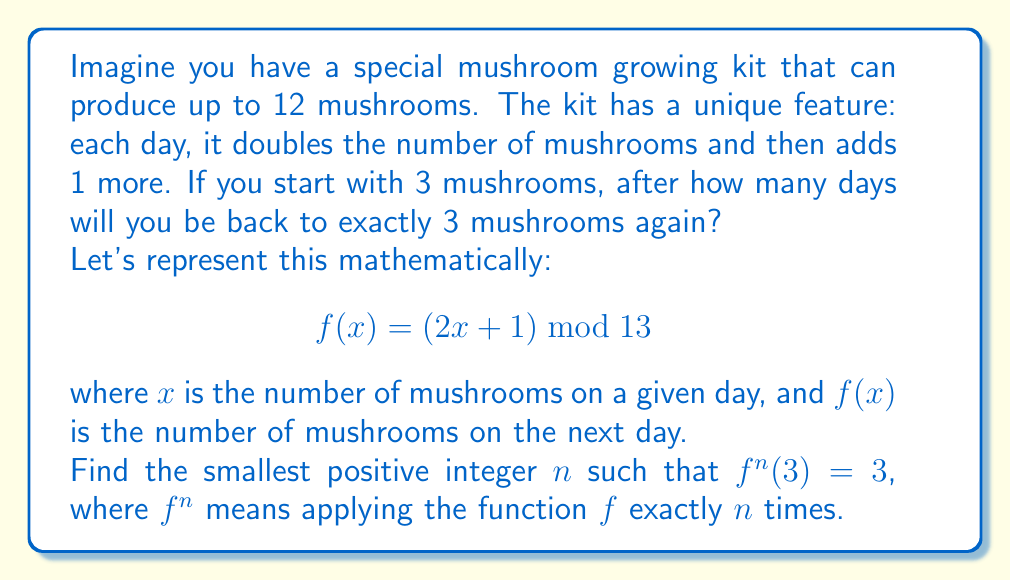Can you solve this math problem? To solve this problem, we need to apply the function repeatedly starting with 3 mushrooms until we get back to 3. This is equivalent to finding the order of the element 3 in the group of transformations defined by the function $f$.

Let's calculate step by step:

1) Start with $x_0 = 3$
2) $x_1 = f(3) = (2 \cdot 3 + 1) \bmod 13 = 7 \bmod 13 = 7$
3) $x_2 = f(7) = (2 \cdot 7 + 1) \bmod 13 = 15 \bmod 13 = 2$
4) $x_3 = f(2) = (2 \cdot 2 + 1) \bmod 13 = 5 \bmod 13 = 5$
5) $x_4 = f(5) = (2 \cdot 5 + 1) \bmod 13 = 11 \bmod 13 = 11$
6) $x_5 = f(11) = (2 \cdot 11 + 1) \bmod 13 = 23 \bmod 13 = 10$
7) $x_6 = f(10) = (2 \cdot 10 + 1) \bmod 13 = 21 \bmod 13 = 8$
8) $x_7 = f(8) = (2 \cdot 8 + 1) \bmod 13 = 17 \bmod 13 = 4$
9) $x_8 = f(4) = (2 \cdot 4 + 1) \bmod 13 = 9 \bmod 13 = 9$
10) $x_9 = f(9) = (2 \cdot 9 + 1) \bmod 13 = 19 \bmod 13 = 6$
11) $x_{10} = f(6) = (2 \cdot 6 + 1) \bmod 13 = 13 \bmod 13 = 0$
12) $x_{11} = f(0) = (2 \cdot 0 + 1) \bmod 13 = 1 \bmod 13 = 1$
13) $x_{12} = f(1) = (2 \cdot 1 + 1) \bmod 13 = 3 \bmod 13 = 3$

We've returned to 3 after 12 steps, so the order of the element 3 in this group is 12.
Answer: 12 